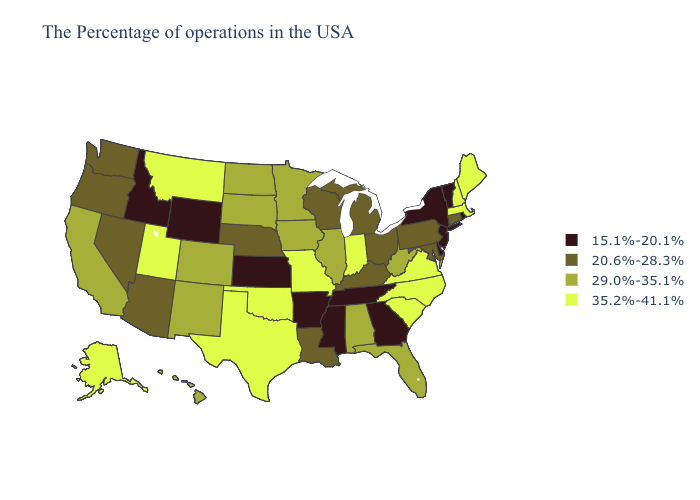What is the value of Kansas?
Give a very brief answer. 15.1%-20.1%. What is the value of West Virginia?
Concise answer only. 29.0%-35.1%. What is the highest value in the Northeast ?
Quick response, please. 35.2%-41.1%. Does Oklahoma have the highest value in the South?
Answer briefly. Yes. Name the states that have a value in the range 29.0%-35.1%?
Short answer required. West Virginia, Florida, Alabama, Illinois, Minnesota, Iowa, South Dakota, North Dakota, Colorado, New Mexico, California, Hawaii. Among the states that border Ohio , which have the lowest value?
Concise answer only. Pennsylvania, Michigan, Kentucky. Does New Mexico have a lower value than South Carolina?
Give a very brief answer. Yes. Does Nebraska have the lowest value in the MidWest?
Concise answer only. No. Name the states that have a value in the range 20.6%-28.3%?
Be succinct. Connecticut, Maryland, Pennsylvania, Ohio, Michigan, Kentucky, Wisconsin, Louisiana, Nebraska, Arizona, Nevada, Washington, Oregon. Among the states that border South Carolina , does Georgia have the lowest value?
Answer briefly. Yes. Does Ohio have a higher value than Louisiana?
Answer briefly. No. Name the states that have a value in the range 29.0%-35.1%?
Short answer required. West Virginia, Florida, Alabama, Illinois, Minnesota, Iowa, South Dakota, North Dakota, Colorado, New Mexico, California, Hawaii. What is the value of West Virginia?
Answer briefly. 29.0%-35.1%. Which states have the lowest value in the USA?
Short answer required. Rhode Island, Vermont, New York, New Jersey, Delaware, Georgia, Tennessee, Mississippi, Arkansas, Kansas, Wyoming, Idaho. Name the states that have a value in the range 35.2%-41.1%?
Keep it brief. Maine, Massachusetts, New Hampshire, Virginia, North Carolina, South Carolina, Indiana, Missouri, Oklahoma, Texas, Utah, Montana, Alaska. 